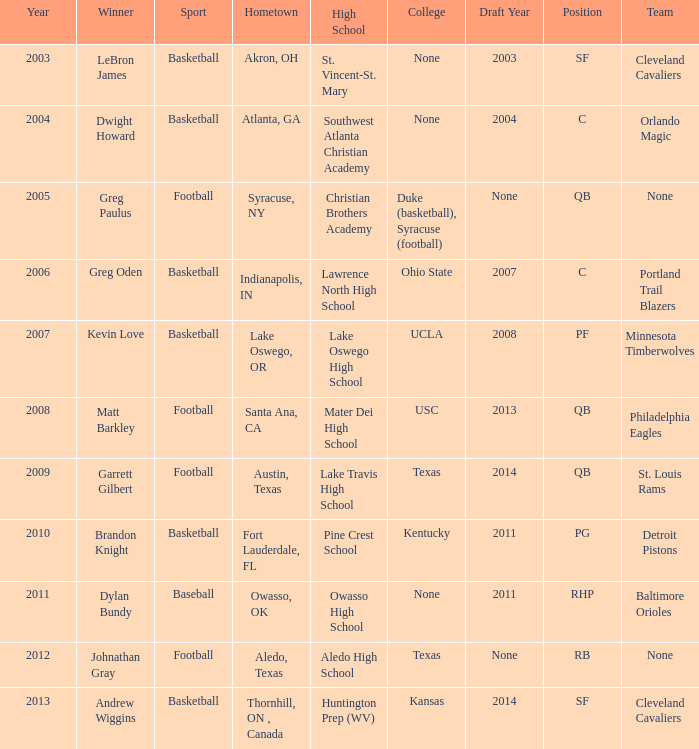What is the total number of Year, when Winner is "Johnathan Gray"? 1.0. 